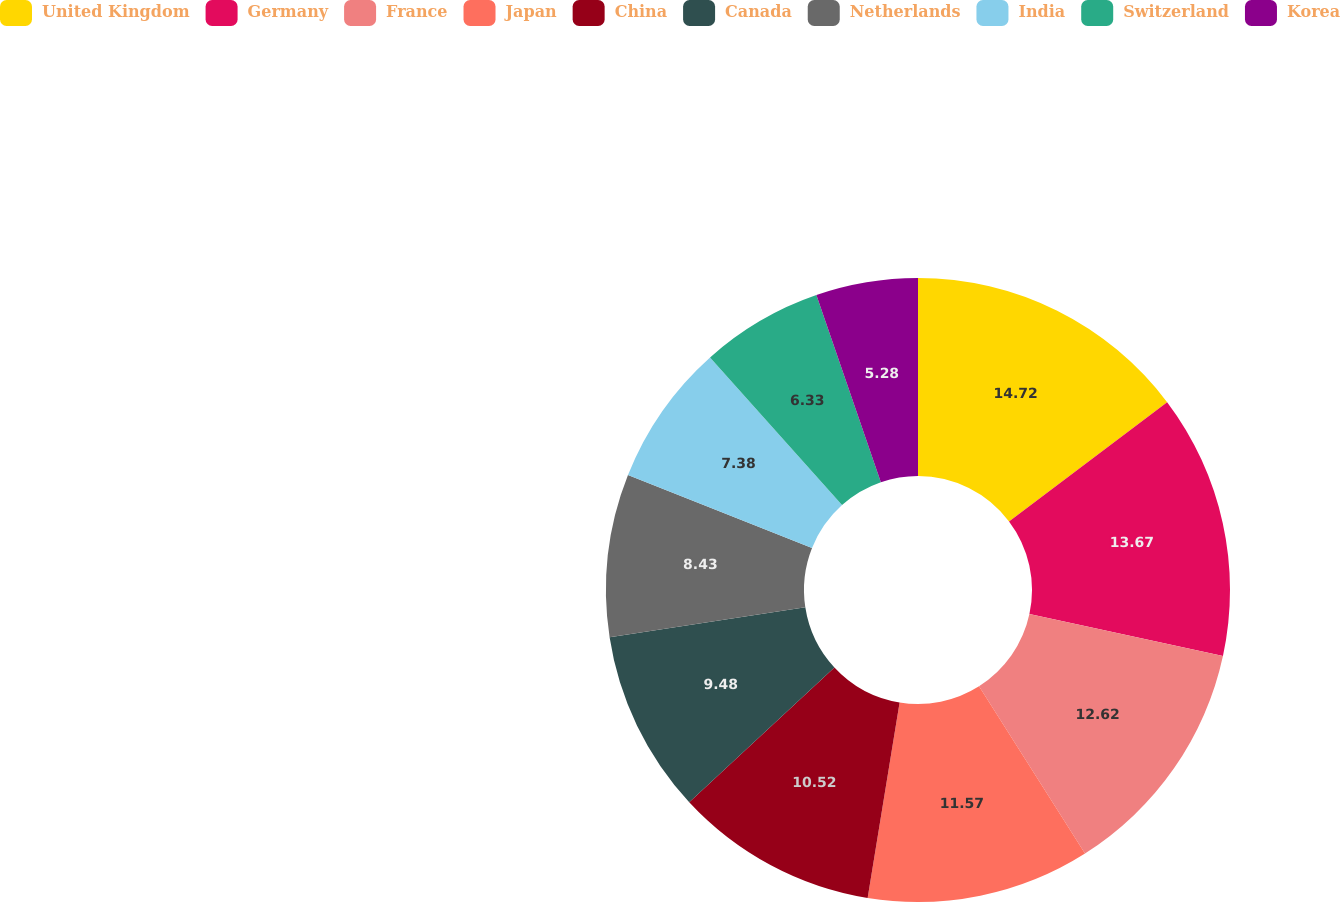Convert chart. <chart><loc_0><loc_0><loc_500><loc_500><pie_chart><fcel>United Kingdom<fcel>Germany<fcel>France<fcel>Japan<fcel>China<fcel>Canada<fcel>Netherlands<fcel>India<fcel>Switzerland<fcel>Korea<nl><fcel>14.72%<fcel>13.67%<fcel>12.62%<fcel>11.57%<fcel>10.52%<fcel>9.48%<fcel>8.43%<fcel>7.38%<fcel>6.33%<fcel>5.28%<nl></chart> 